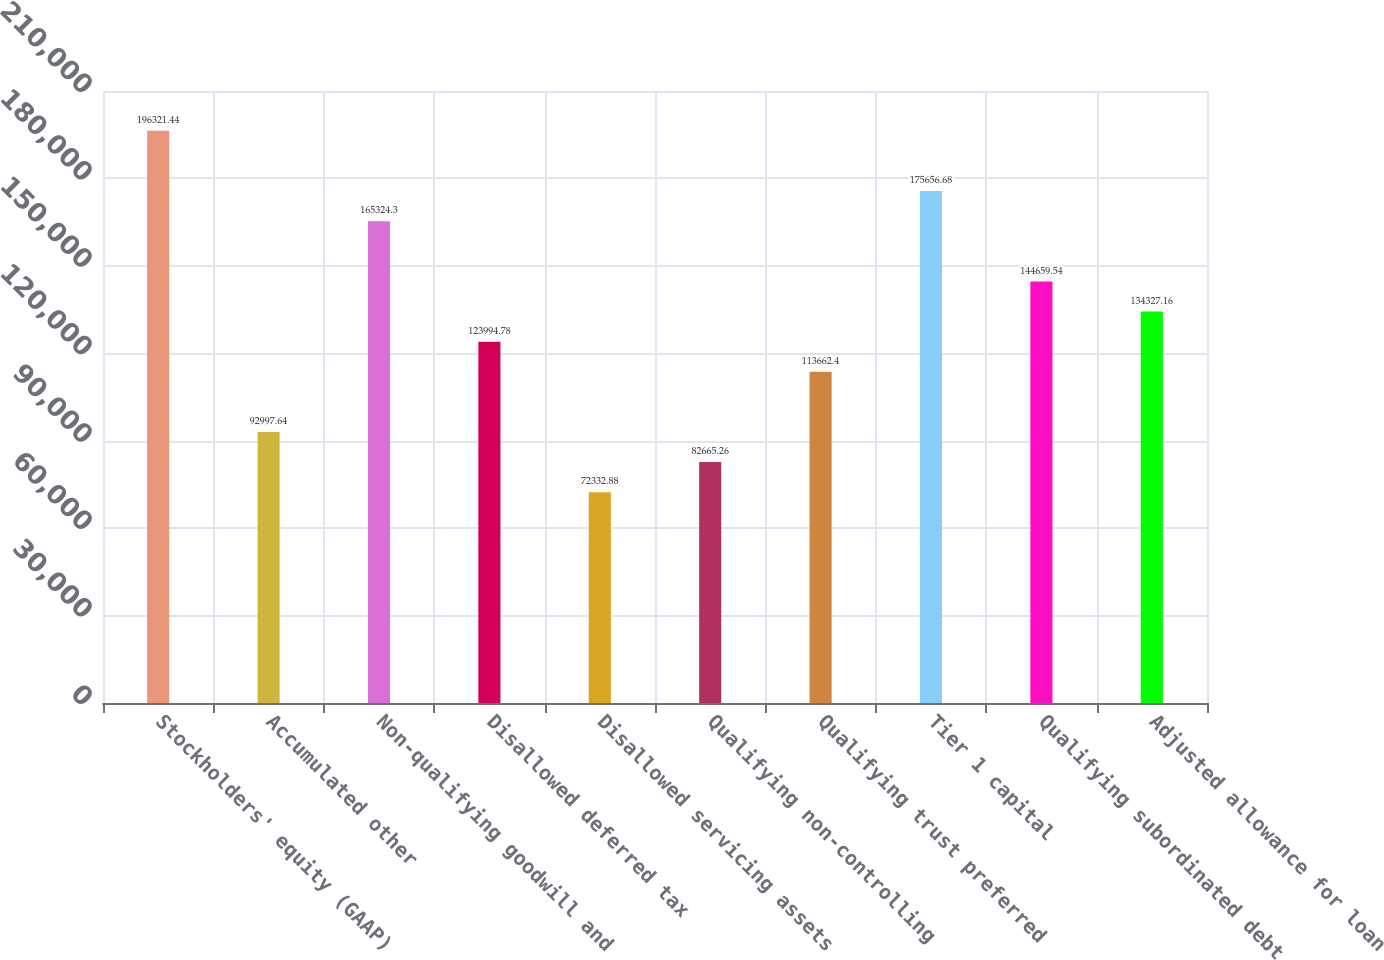<chart> <loc_0><loc_0><loc_500><loc_500><bar_chart><fcel>Stockholders' equity (GAAP)<fcel>Accumulated other<fcel>Non-qualifying goodwill and<fcel>Disallowed deferred tax<fcel>Disallowed servicing assets<fcel>Qualifying non-controlling<fcel>Qualifying trust preferred<fcel>Tier 1 capital<fcel>Qualifying subordinated debt<fcel>Adjusted allowance for loan<nl><fcel>196321<fcel>92997.6<fcel>165324<fcel>123995<fcel>72332.9<fcel>82665.3<fcel>113662<fcel>175657<fcel>144660<fcel>134327<nl></chart> 